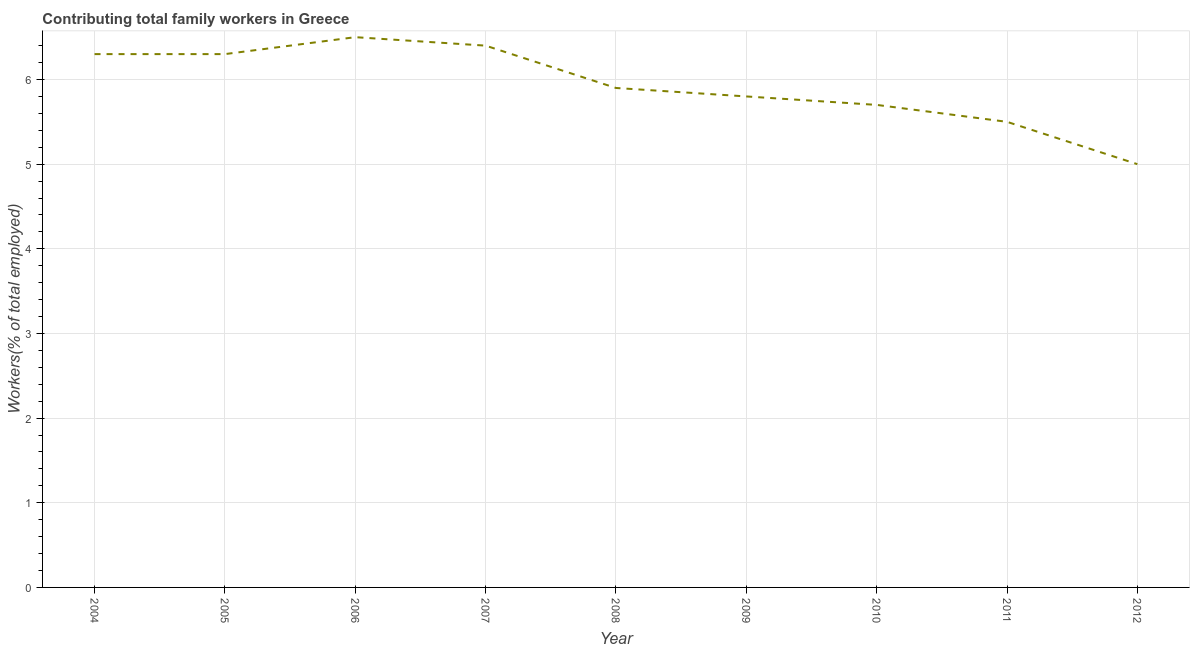What is the contributing family workers in 2007?
Offer a very short reply. 6.4. What is the sum of the contributing family workers?
Give a very brief answer. 53.4. What is the difference between the contributing family workers in 2011 and 2012?
Offer a terse response. 0.5. What is the average contributing family workers per year?
Your response must be concise. 5.93. What is the median contributing family workers?
Ensure brevity in your answer.  5.9. In how many years, is the contributing family workers greater than 2 %?
Your answer should be compact. 9. Do a majority of the years between 2010 and 2004 (inclusive) have contributing family workers greater than 2.6 %?
Offer a terse response. Yes. What is the ratio of the contributing family workers in 2008 to that in 2011?
Your answer should be very brief. 1.07. Is the difference between the contributing family workers in 2005 and 2006 greater than the difference between any two years?
Your answer should be very brief. No. What is the difference between the highest and the second highest contributing family workers?
Offer a very short reply. 0.1. Is the sum of the contributing family workers in 2006 and 2007 greater than the maximum contributing family workers across all years?
Keep it short and to the point. Yes. What is the difference between the highest and the lowest contributing family workers?
Ensure brevity in your answer.  1.5. Does the contributing family workers monotonically increase over the years?
Make the answer very short. No. How many lines are there?
Offer a terse response. 1. What is the difference between two consecutive major ticks on the Y-axis?
Your answer should be very brief. 1. Does the graph contain any zero values?
Keep it short and to the point. No. Does the graph contain grids?
Your answer should be very brief. Yes. What is the title of the graph?
Provide a short and direct response. Contributing total family workers in Greece. What is the label or title of the Y-axis?
Offer a terse response. Workers(% of total employed). What is the Workers(% of total employed) of 2004?
Keep it short and to the point. 6.3. What is the Workers(% of total employed) in 2005?
Provide a short and direct response. 6.3. What is the Workers(% of total employed) in 2006?
Make the answer very short. 6.5. What is the Workers(% of total employed) of 2007?
Offer a terse response. 6.4. What is the Workers(% of total employed) of 2008?
Your response must be concise. 5.9. What is the Workers(% of total employed) of 2009?
Ensure brevity in your answer.  5.8. What is the Workers(% of total employed) of 2010?
Offer a terse response. 5.7. What is the difference between the Workers(% of total employed) in 2004 and 2008?
Offer a very short reply. 0.4. What is the difference between the Workers(% of total employed) in 2004 and 2009?
Ensure brevity in your answer.  0.5. What is the difference between the Workers(% of total employed) in 2004 and 2012?
Offer a terse response. 1.3. What is the difference between the Workers(% of total employed) in 2005 and 2009?
Offer a very short reply. 0.5. What is the difference between the Workers(% of total employed) in 2005 and 2010?
Give a very brief answer. 0.6. What is the difference between the Workers(% of total employed) in 2006 and 2007?
Your response must be concise. 0.1. What is the difference between the Workers(% of total employed) in 2006 and 2009?
Provide a succinct answer. 0.7. What is the difference between the Workers(% of total employed) in 2006 and 2010?
Provide a succinct answer. 0.8. What is the difference between the Workers(% of total employed) in 2006 and 2011?
Make the answer very short. 1. What is the difference between the Workers(% of total employed) in 2006 and 2012?
Ensure brevity in your answer.  1.5. What is the difference between the Workers(% of total employed) in 2008 and 2009?
Your answer should be very brief. 0.1. What is the difference between the Workers(% of total employed) in 2008 and 2012?
Offer a terse response. 0.9. What is the difference between the Workers(% of total employed) in 2009 and 2010?
Your response must be concise. 0.1. What is the difference between the Workers(% of total employed) in 2010 and 2012?
Give a very brief answer. 0.7. What is the difference between the Workers(% of total employed) in 2011 and 2012?
Offer a terse response. 0.5. What is the ratio of the Workers(% of total employed) in 2004 to that in 2005?
Make the answer very short. 1. What is the ratio of the Workers(% of total employed) in 2004 to that in 2006?
Offer a very short reply. 0.97. What is the ratio of the Workers(% of total employed) in 2004 to that in 2008?
Provide a succinct answer. 1.07. What is the ratio of the Workers(% of total employed) in 2004 to that in 2009?
Your answer should be compact. 1.09. What is the ratio of the Workers(% of total employed) in 2004 to that in 2010?
Offer a very short reply. 1.1. What is the ratio of the Workers(% of total employed) in 2004 to that in 2011?
Your answer should be compact. 1.15. What is the ratio of the Workers(% of total employed) in 2004 to that in 2012?
Your answer should be very brief. 1.26. What is the ratio of the Workers(% of total employed) in 2005 to that in 2006?
Make the answer very short. 0.97. What is the ratio of the Workers(% of total employed) in 2005 to that in 2008?
Your answer should be compact. 1.07. What is the ratio of the Workers(% of total employed) in 2005 to that in 2009?
Ensure brevity in your answer.  1.09. What is the ratio of the Workers(% of total employed) in 2005 to that in 2010?
Keep it short and to the point. 1.1. What is the ratio of the Workers(% of total employed) in 2005 to that in 2011?
Offer a very short reply. 1.15. What is the ratio of the Workers(% of total employed) in 2005 to that in 2012?
Make the answer very short. 1.26. What is the ratio of the Workers(% of total employed) in 2006 to that in 2008?
Offer a very short reply. 1.1. What is the ratio of the Workers(% of total employed) in 2006 to that in 2009?
Ensure brevity in your answer.  1.12. What is the ratio of the Workers(% of total employed) in 2006 to that in 2010?
Your answer should be compact. 1.14. What is the ratio of the Workers(% of total employed) in 2006 to that in 2011?
Offer a terse response. 1.18. What is the ratio of the Workers(% of total employed) in 2007 to that in 2008?
Make the answer very short. 1.08. What is the ratio of the Workers(% of total employed) in 2007 to that in 2009?
Offer a very short reply. 1.1. What is the ratio of the Workers(% of total employed) in 2007 to that in 2010?
Offer a terse response. 1.12. What is the ratio of the Workers(% of total employed) in 2007 to that in 2011?
Provide a succinct answer. 1.16. What is the ratio of the Workers(% of total employed) in 2007 to that in 2012?
Provide a succinct answer. 1.28. What is the ratio of the Workers(% of total employed) in 2008 to that in 2010?
Provide a succinct answer. 1.03. What is the ratio of the Workers(% of total employed) in 2008 to that in 2011?
Provide a short and direct response. 1.07. What is the ratio of the Workers(% of total employed) in 2008 to that in 2012?
Give a very brief answer. 1.18. What is the ratio of the Workers(% of total employed) in 2009 to that in 2011?
Provide a short and direct response. 1.05. What is the ratio of the Workers(% of total employed) in 2009 to that in 2012?
Make the answer very short. 1.16. What is the ratio of the Workers(% of total employed) in 2010 to that in 2011?
Your answer should be very brief. 1.04. What is the ratio of the Workers(% of total employed) in 2010 to that in 2012?
Make the answer very short. 1.14. What is the ratio of the Workers(% of total employed) in 2011 to that in 2012?
Your response must be concise. 1.1. 